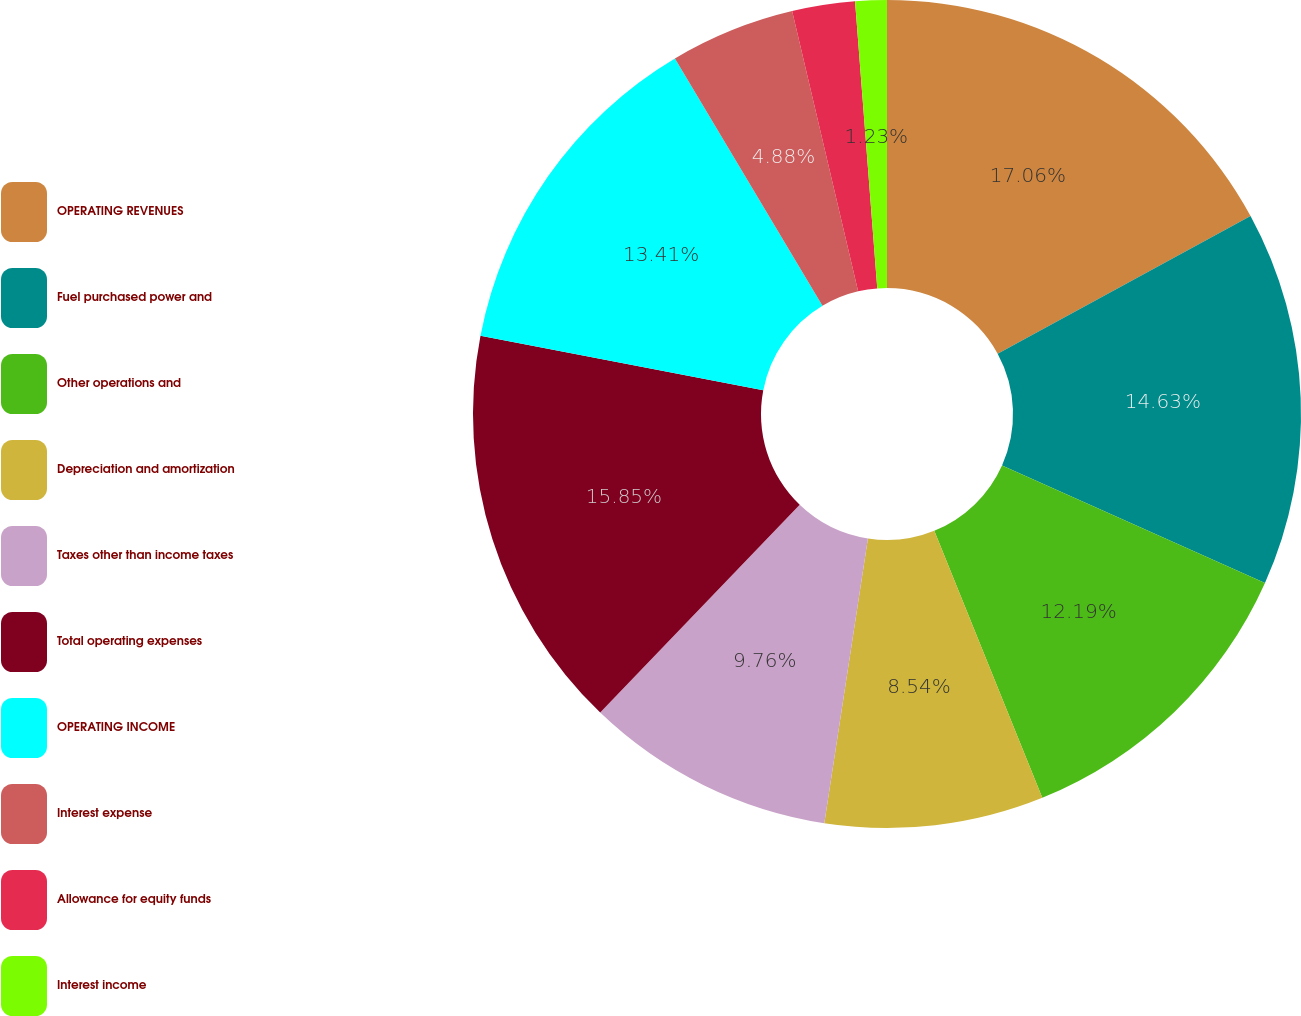Convert chart. <chart><loc_0><loc_0><loc_500><loc_500><pie_chart><fcel>OPERATING REVENUES<fcel>Fuel purchased power and<fcel>Other operations and<fcel>Depreciation and amortization<fcel>Taxes other than income taxes<fcel>Total operating expenses<fcel>OPERATING INCOME<fcel>Interest expense<fcel>Allowance for equity funds<fcel>Interest income<nl><fcel>17.06%<fcel>14.63%<fcel>12.19%<fcel>8.54%<fcel>9.76%<fcel>15.85%<fcel>13.41%<fcel>4.88%<fcel>2.45%<fcel>1.23%<nl></chart> 